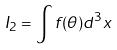Convert formula to latex. <formula><loc_0><loc_0><loc_500><loc_500>I _ { 2 } = \int f ( \theta ) d ^ { 3 } x</formula> 